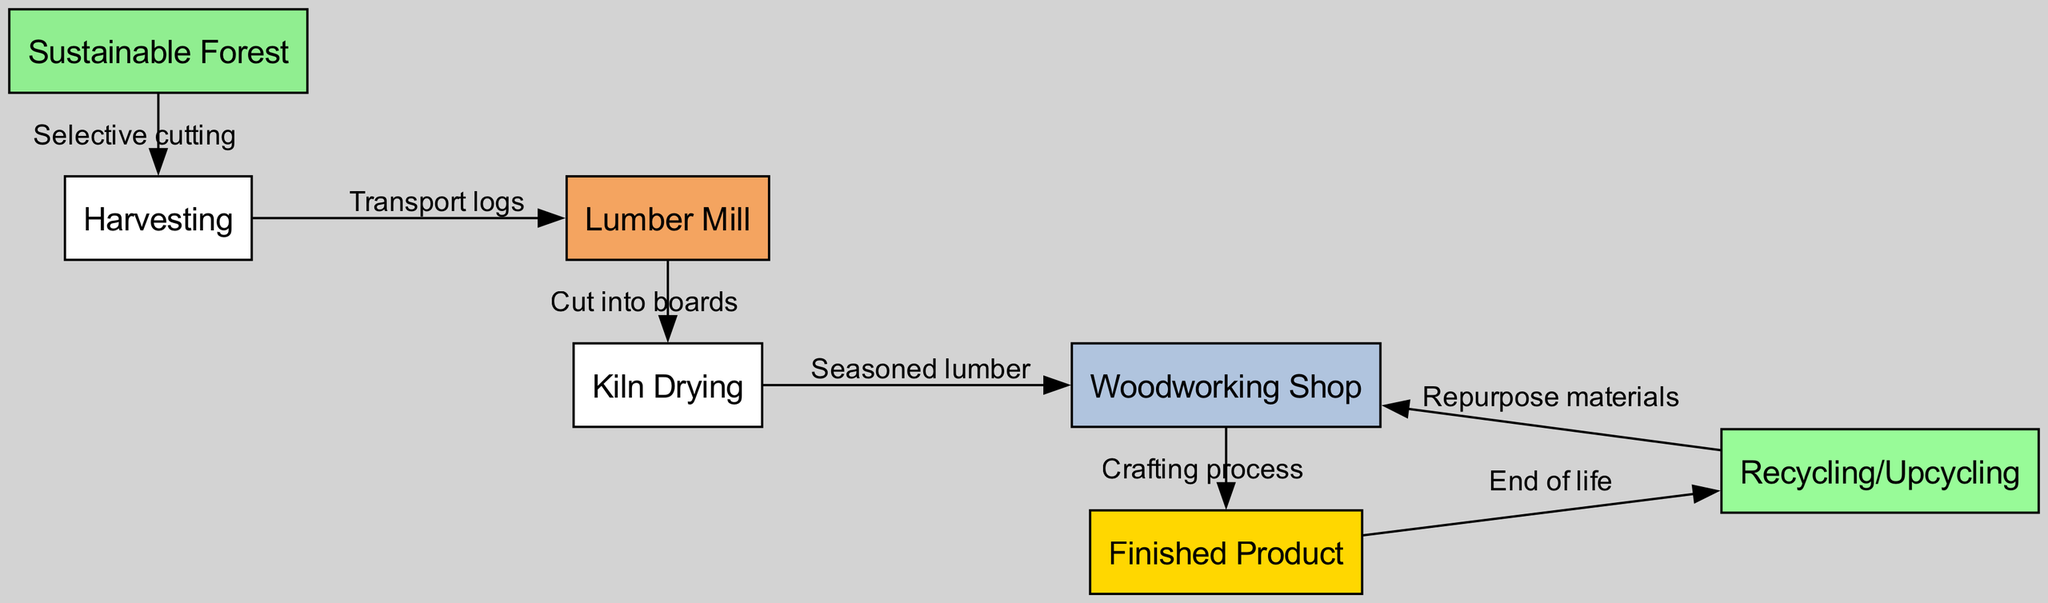What is the first step in the lifecycle of sustainable wood products? The diagram indicates that the first step is "Sustainable Forest," which is represented as the starting node for the lifecycle.
Answer: Sustainable Forest How many nodes are in the diagram? By counting the unique entities represented in the diagram (Sustainable Forest, Harvesting, Lumber Mill, Kiln Drying, Woodworking Shop, Finished Product, Recycling/Upcycling), there are a total of 7 nodes.
Answer: 7 What process follows "Kiln Drying"? In the flow of the diagram, "Kiln Drying" is followed by "Woodworking Shop," indicating that the seasoned lumber moves to this stage next.
Answer: Woodworking Shop What is the relationship between "Lumber Mill" and "Kiln Drying"? The relationship is that lumber is cut into boards at the Lumber Mill, which then proceeds to the Kiln Drying stage, as connected by the edge labeled "Cut into boards."
Answer: Cut into boards Which node represents the final output in the lifecycle? The final output of the lifecycle is represented by the node labeled "Finished Product," which is the ultimate result of the crafting process from the Woodworking Shop.
Answer: Finished Product What happens to the finished product at the end of its lifecycle? According to the diagram, the finished product moves to "Recycling/Upcycling," which indicates that at the end of its lifecycle, it can be repurposed.
Answer: Recycling/Upcycling How does the "Recycling/Upcycling" phase connect back to another part of the lifecycle? The diagram shows that "Recycling/Upcycling" connects back to "Woodworking Shop" with an edge labeled "Repurpose materials," indicating that materials can be reused in the crafting process.
Answer: Repurpose materials What type of cutting method is used during the harvesting process? The harvesting method specified in the diagram is "Selective cutting," which refers to the careful removal of trees from the sustainable forest to promote healthier ecosystem growth.
Answer: Selective cutting 